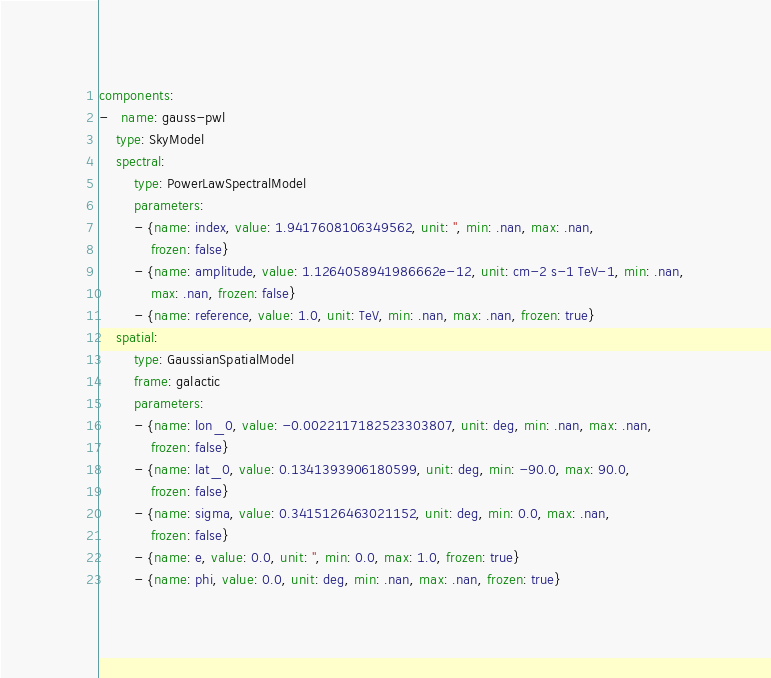Convert code to text. <code><loc_0><loc_0><loc_500><loc_500><_YAML_>components:
-   name: gauss-pwl
    type: SkyModel
    spectral:
        type: PowerLawSpectralModel
        parameters:
        - {name: index, value: 1.9417608106349562, unit: '', min: .nan, max: .nan,
            frozen: false}
        - {name: amplitude, value: 1.1264058941986662e-12, unit: cm-2 s-1 TeV-1, min: .nan,
            max: .nan, frozen: false}
        - {name: reference, value: 1.0, unit: TeV, min: .nan, max: .nan, frozen: true}
    spatial:
        type: GaussianSpatialModel
        frame: galactic
        parameters:
        - {name: lon_0, value: -0.0022117182523303807, unit: deg, min: .nan, max: .nan,
            frozen: false}
        - {name: lat_0, value: 0.1341393906180599, unit: deg, min: -90.0, max: 90.0,
            frozen: false}
        - {name: sigma, value: 0.3415126463021152, unit: deg, min: 0.0, max: .nan,
            frozen: false}
        - {name: e, value: 0.0, unit: '', min: 0.0, max: 1.0, frozen: true}
        - {name: phi, value: 0.0, unit: deg, min: .nan, max: .nan, frozen: true}
</code> 